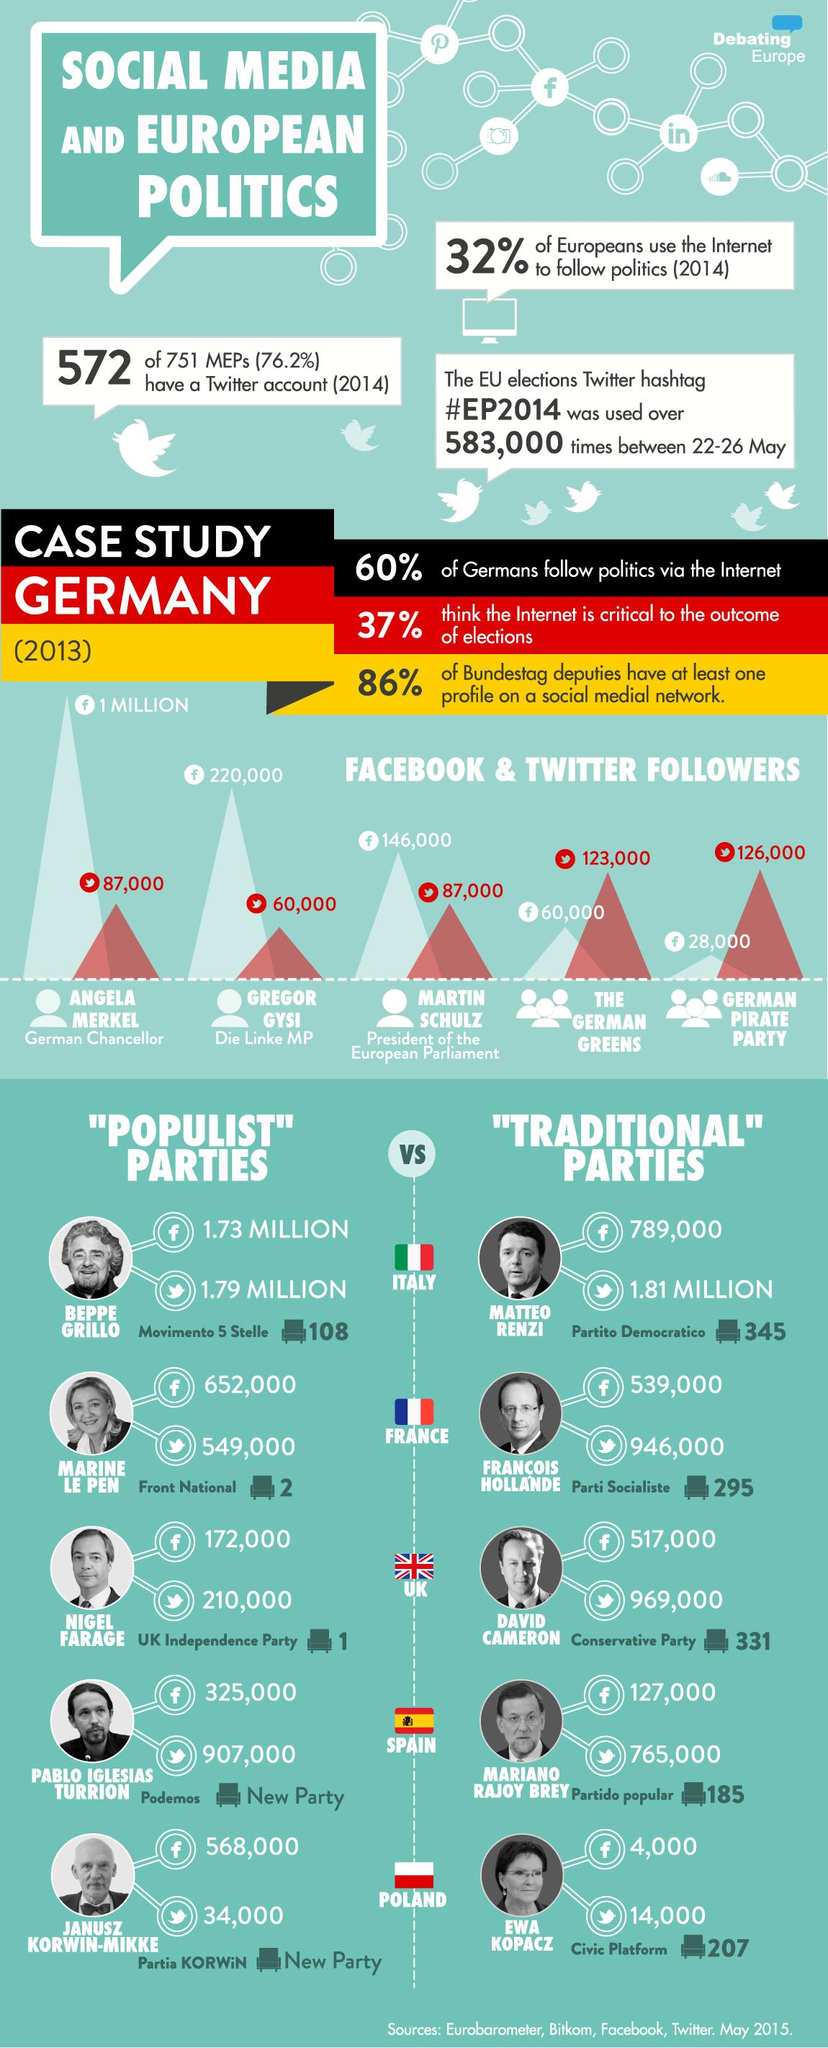List a handful of essential elements in this visual. In 2013, the German Greens party had approximately 60,000 followers on Facebook. In 2013, the German Pirate Party had approximately 126,000 Twitter followers. In 2013, Angela Merkel was the German Chancellor. As of May 2015, Marine Le Pen had approximately 652,000 followers on Facebook. As of May 2015, Matteo Renzi was the Italian politician with the largest number of Twitter followers. 